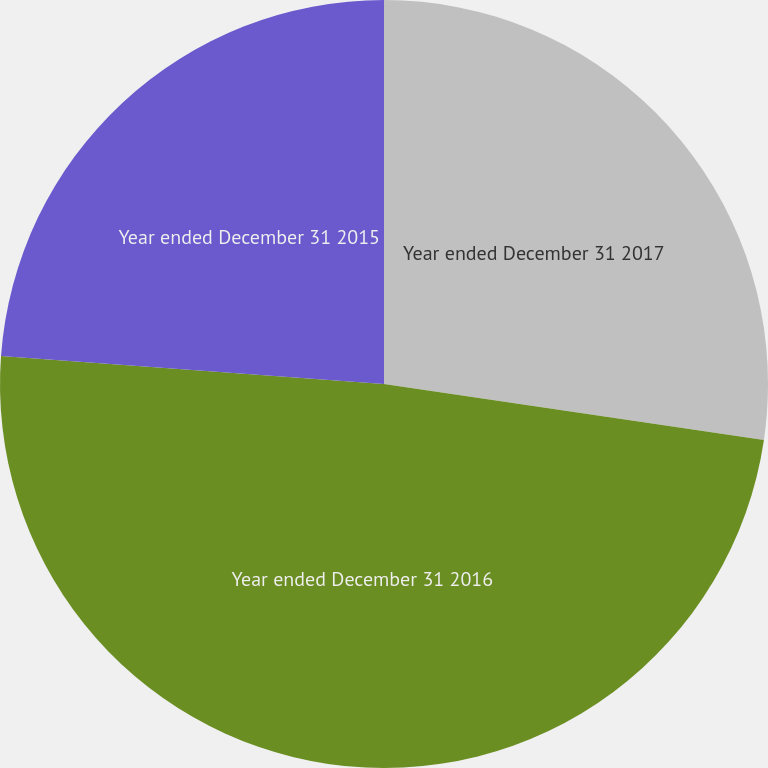Convert chart to OTSL. <chart><loc_0><loc_0><loc_500><loc_500><pie_chart><fcel>Year ended December 31 2017<fcel>Year ended December 31 2016<fcel>Year ended December 31 2015<nl><fcel>27.33%<fcel>48.84%<fcel>23.84%<nl></chart> 